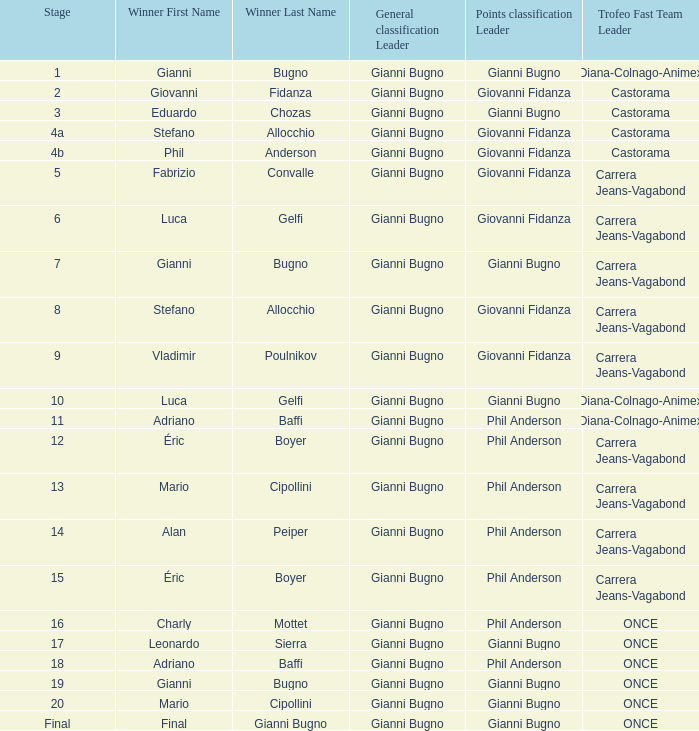What is the stage when the winner is charly mottet? 16.0. 